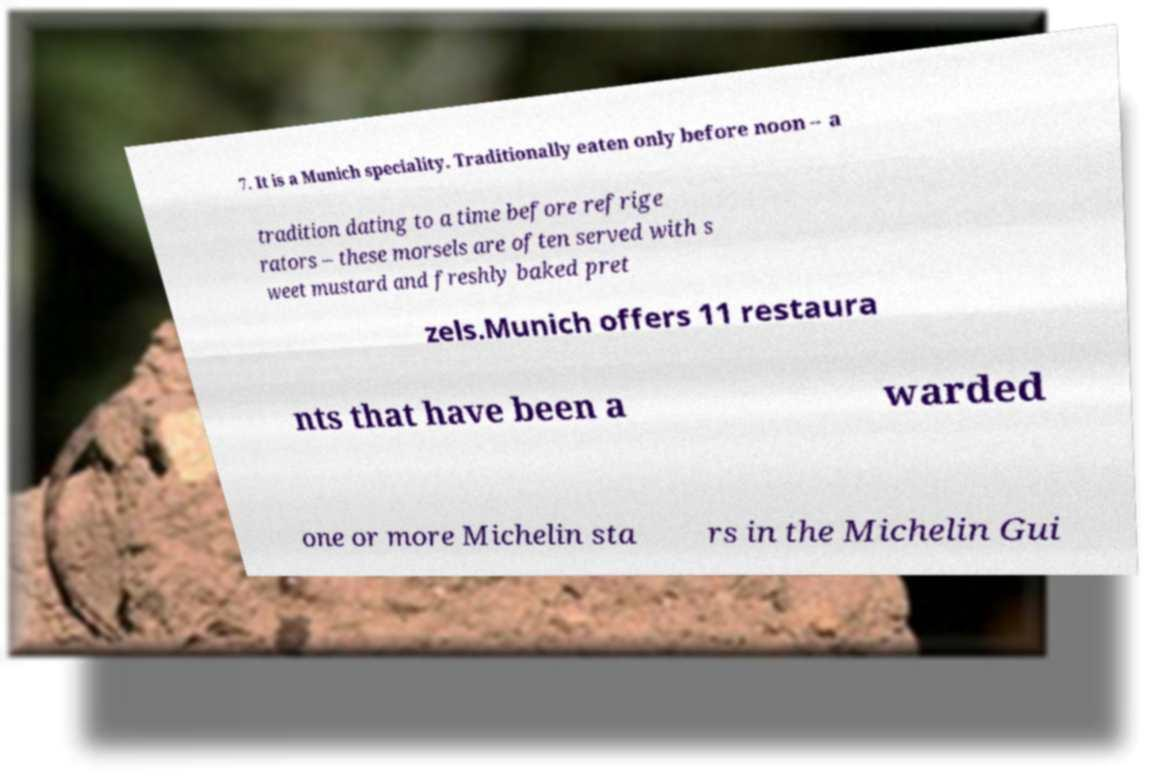There's text embedded in this image that I need extracted. Can you transcribe it verbatim? 7. It is a Munich speciality. Traditionally eaten only before noon – a tradition dating to a time before refrige rators – these morsels are often served with s weet mustard and freshly baked pret zels.Munich offers 11 restaura nts that have been a warded one or more Michelin sta rs in the Michelin Gui 